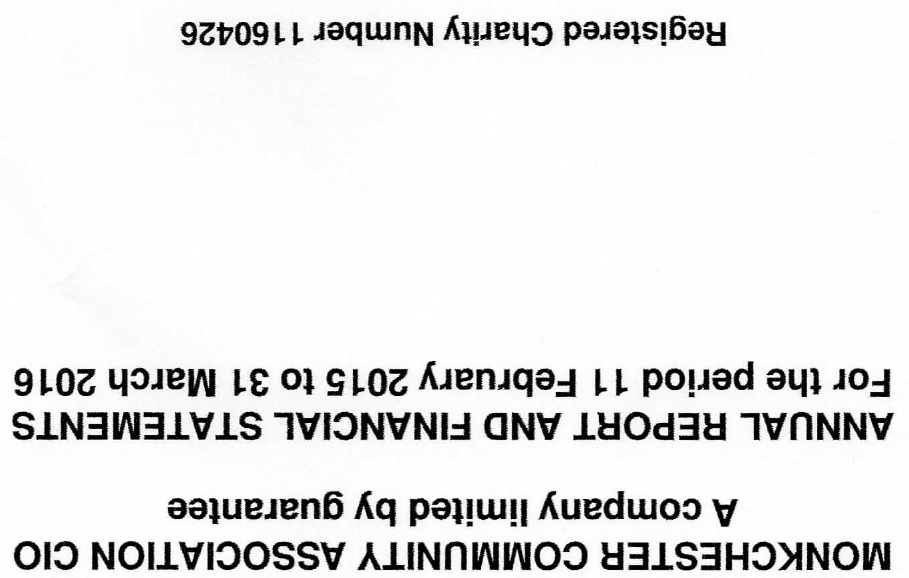What is the value for the spending_annually_in_british_pounds?
Answer the question using a single word or phrase. None 